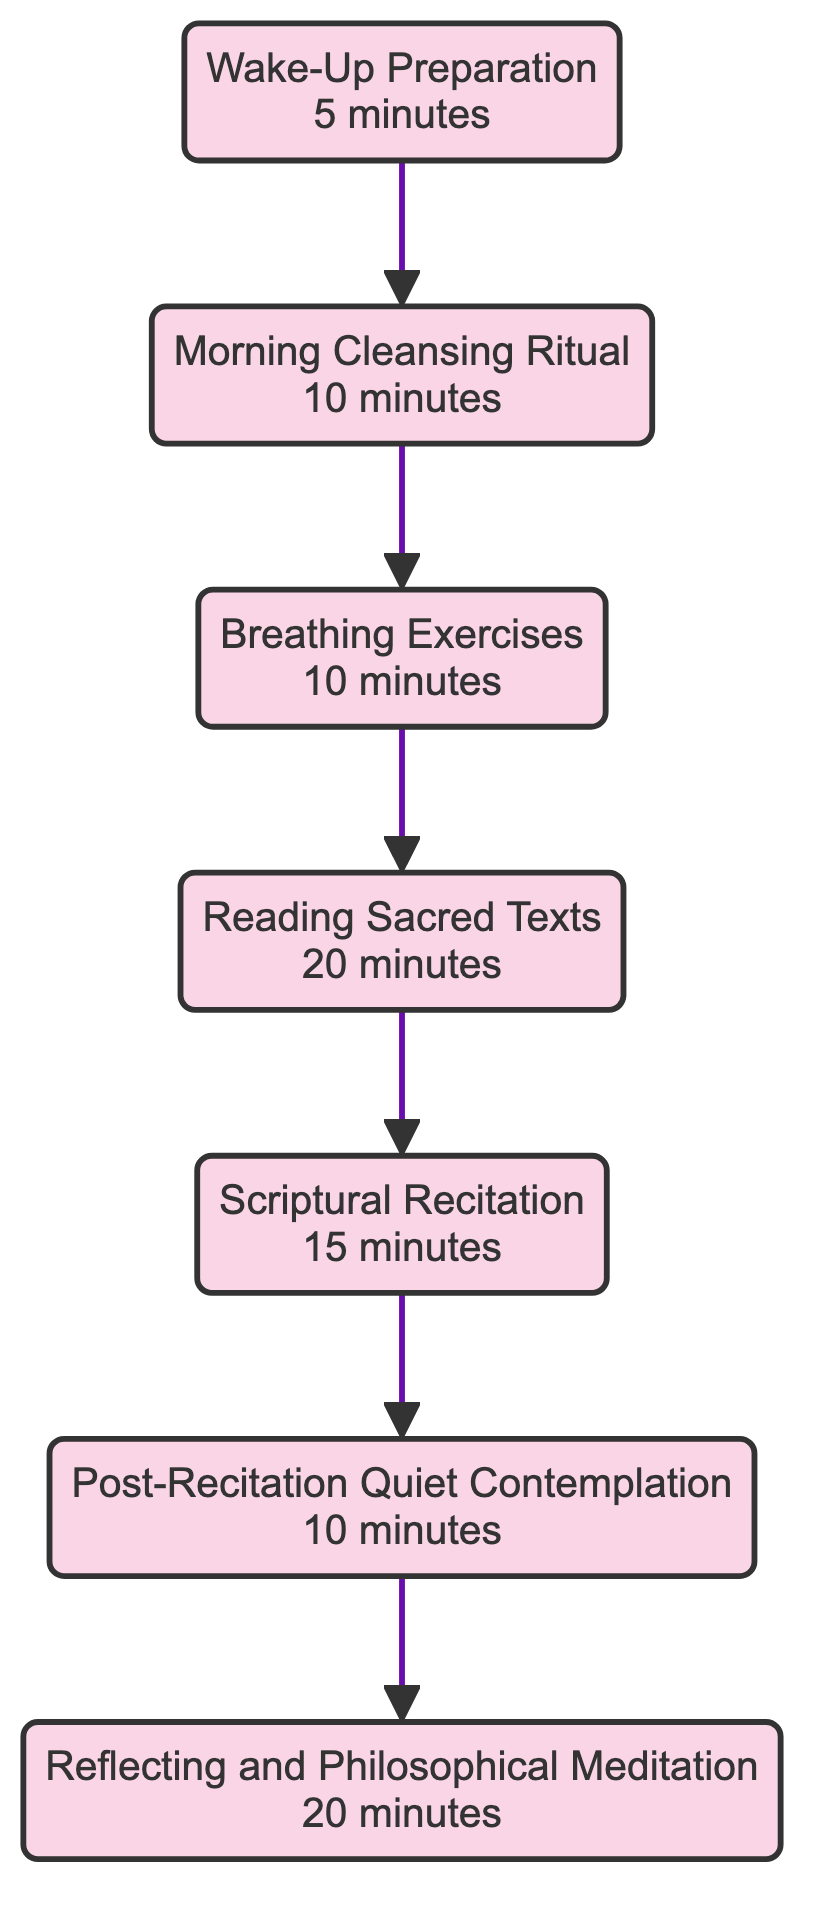What is the first activity listed in the diagram? The first activity in the flowchart is determined by tracing the flow upwards from the bottom. The last node at the bottom, "Wake-Up Preparation," is considered the initial step in the routine.
Answer: Wake-Up Preparation How many total activities are included in the daily routine? By counting each node in the flowchart, we can see there are seven distinct activities.
Answer: 7 What is the duration of “Scriptural Recitation”? Looking at the activity labeled "Scriptural Recitation" in the diagram, the duration associated with it is specified as "15 minutes."
Answer: 15 minutes Which activity follows “Reading Sacred Texts” in the sequence? Tracing the flow from the node "Reading Sacred Texts," the next node that follows in the order is "Scriptural Recitation."
Answer: Scriptural Recitation What is the combined duration of the first three activities? The first three activities are "Wake-Up Preparation," "Morning Cleansing Ritual," and "Breathing Exercises" with durations of 5, 10, and 10 minutes respectively. Adding these together gives a total of 25 minutes.
Answer: 25 minutes What do you do immediately after “Post-Recitation Quiet Contemplation”? The flow indicates that after "Post-Recitation Quiet Contemplation," the next activity is "Reflecting and Philosophical Meditation."
Answer: Reflecting and Philosophical Meditation Which activity has the longest duration? By comparing the durations listed for each activity, "Reading Sacred Texts" at 20 minutes is the longest duration.
Answer: Reading Sacred Texts What is the duration of the last activity in the sequence? Checking the node at the top of the flowchart, "Reflecting and Philosophical Meditation" has a duration of 20 minutes assigned to it.
Answer: 20 minutes 